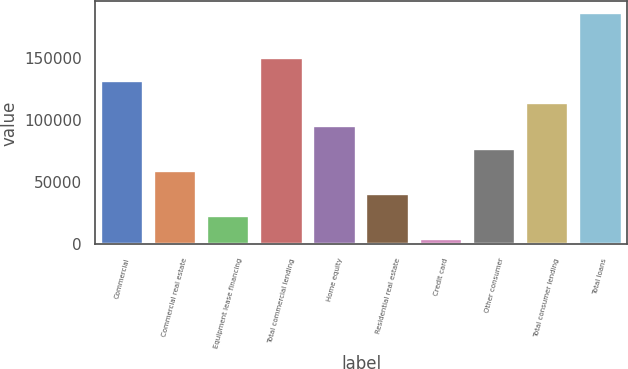<chart> <loc_0><loc_0><loc_500><loc_500><bar_chart><fcel>Commercial<fcel>Commercial real estate<fcel>Equipment lease financing<fcel>Total commercial lending<fcel>Home equity<fcel>Residential real estate<fcel>Credit card<fcel>Other consumer<fcel>Total consumer lending<fcel>Total loans<nl><fcel>131390<fcel>58768.9<fcel>22458.3<fcel>149545<fcel>95079.5<fcel>40613.6<fcel>4303<fcel>76924.2<fcel>113235<fcel>185856<nl></chart> 